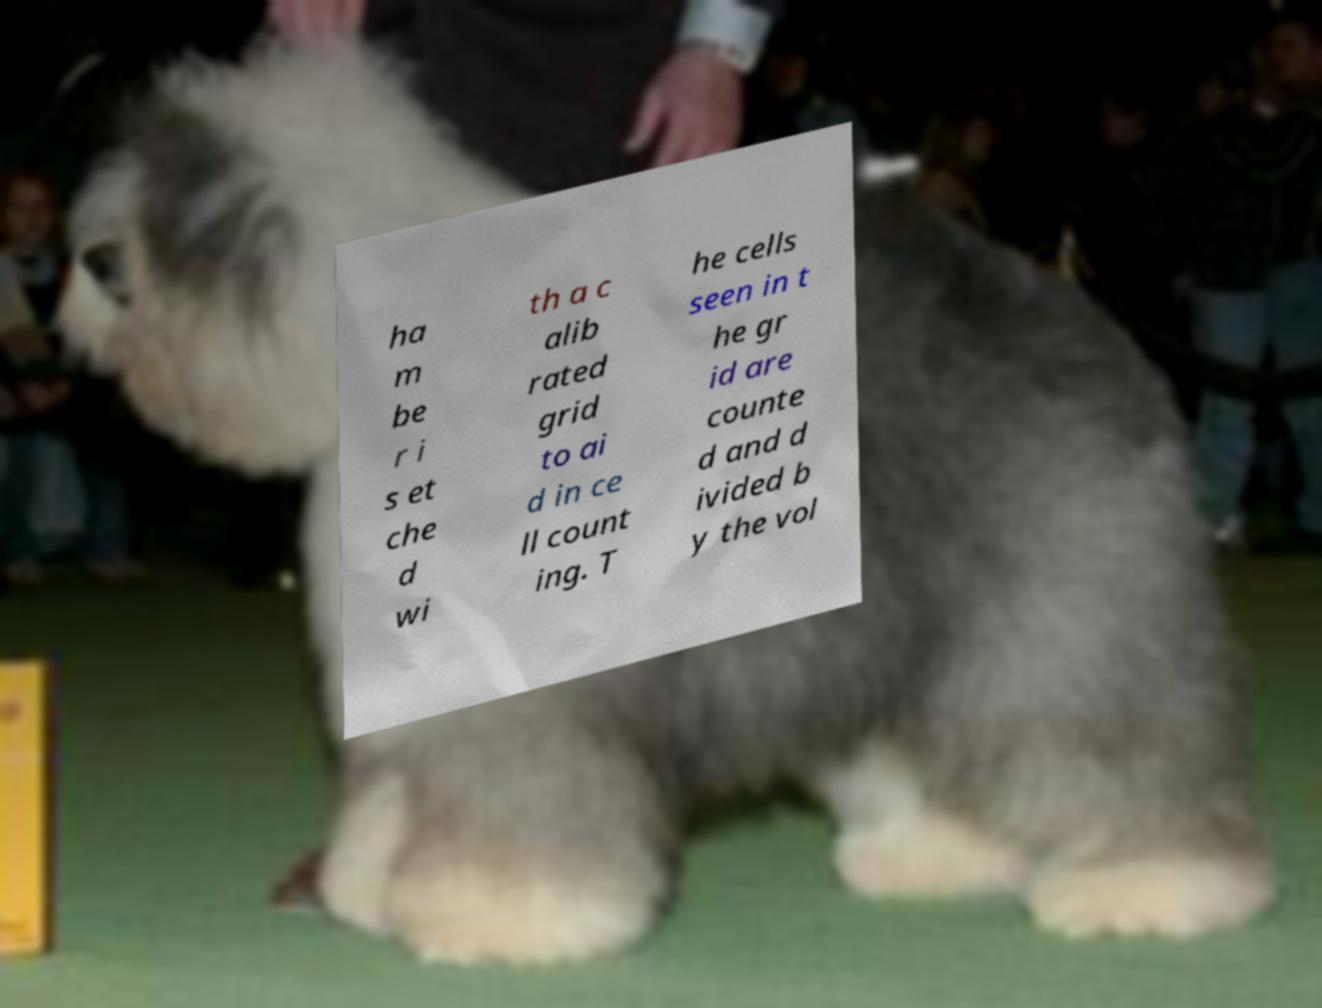Please read and relay the text visible in this image. What does it say? ha m be r i s et che d wi th a c alib rated grid to ai d in ce ll count ing. T he cells seen in t he gr id are counte d and d ivided b y the vol 